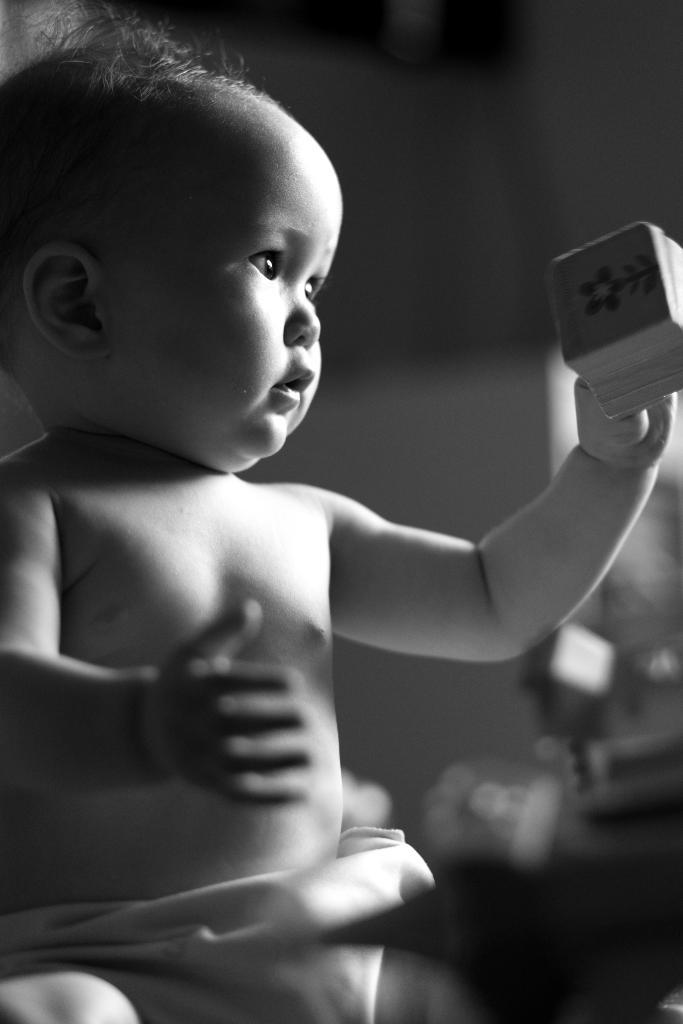What is the color scheme of the image? The image is black and white. What can be seen in the foreground of the image? There is a baby in the image. What is the baby holding in their hand? The baby is holding something in their hand. Can you describe the background of the image? The background of the image is blurry. Can you see a rat in the image? No, there is no rat present in the image. 